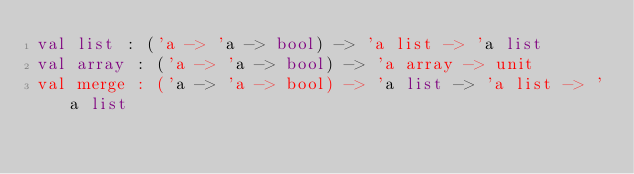<code> <loc_0><loc_0><loc_500><loc_500><_OCaml_>val list : ('a -> 'a -> bool) -> 'a list -> 'a list
val array : ('a -> 'a -> bool) -> 'a array -> unit
val merge : ('a -> 'a -> bool) -> 'a list -> 'a list -> 'a list
</code> 